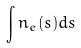<formula> <loc_0><loc_0><loc_500><loc_500>\int n _ { e } ( s ) d s</formula> 